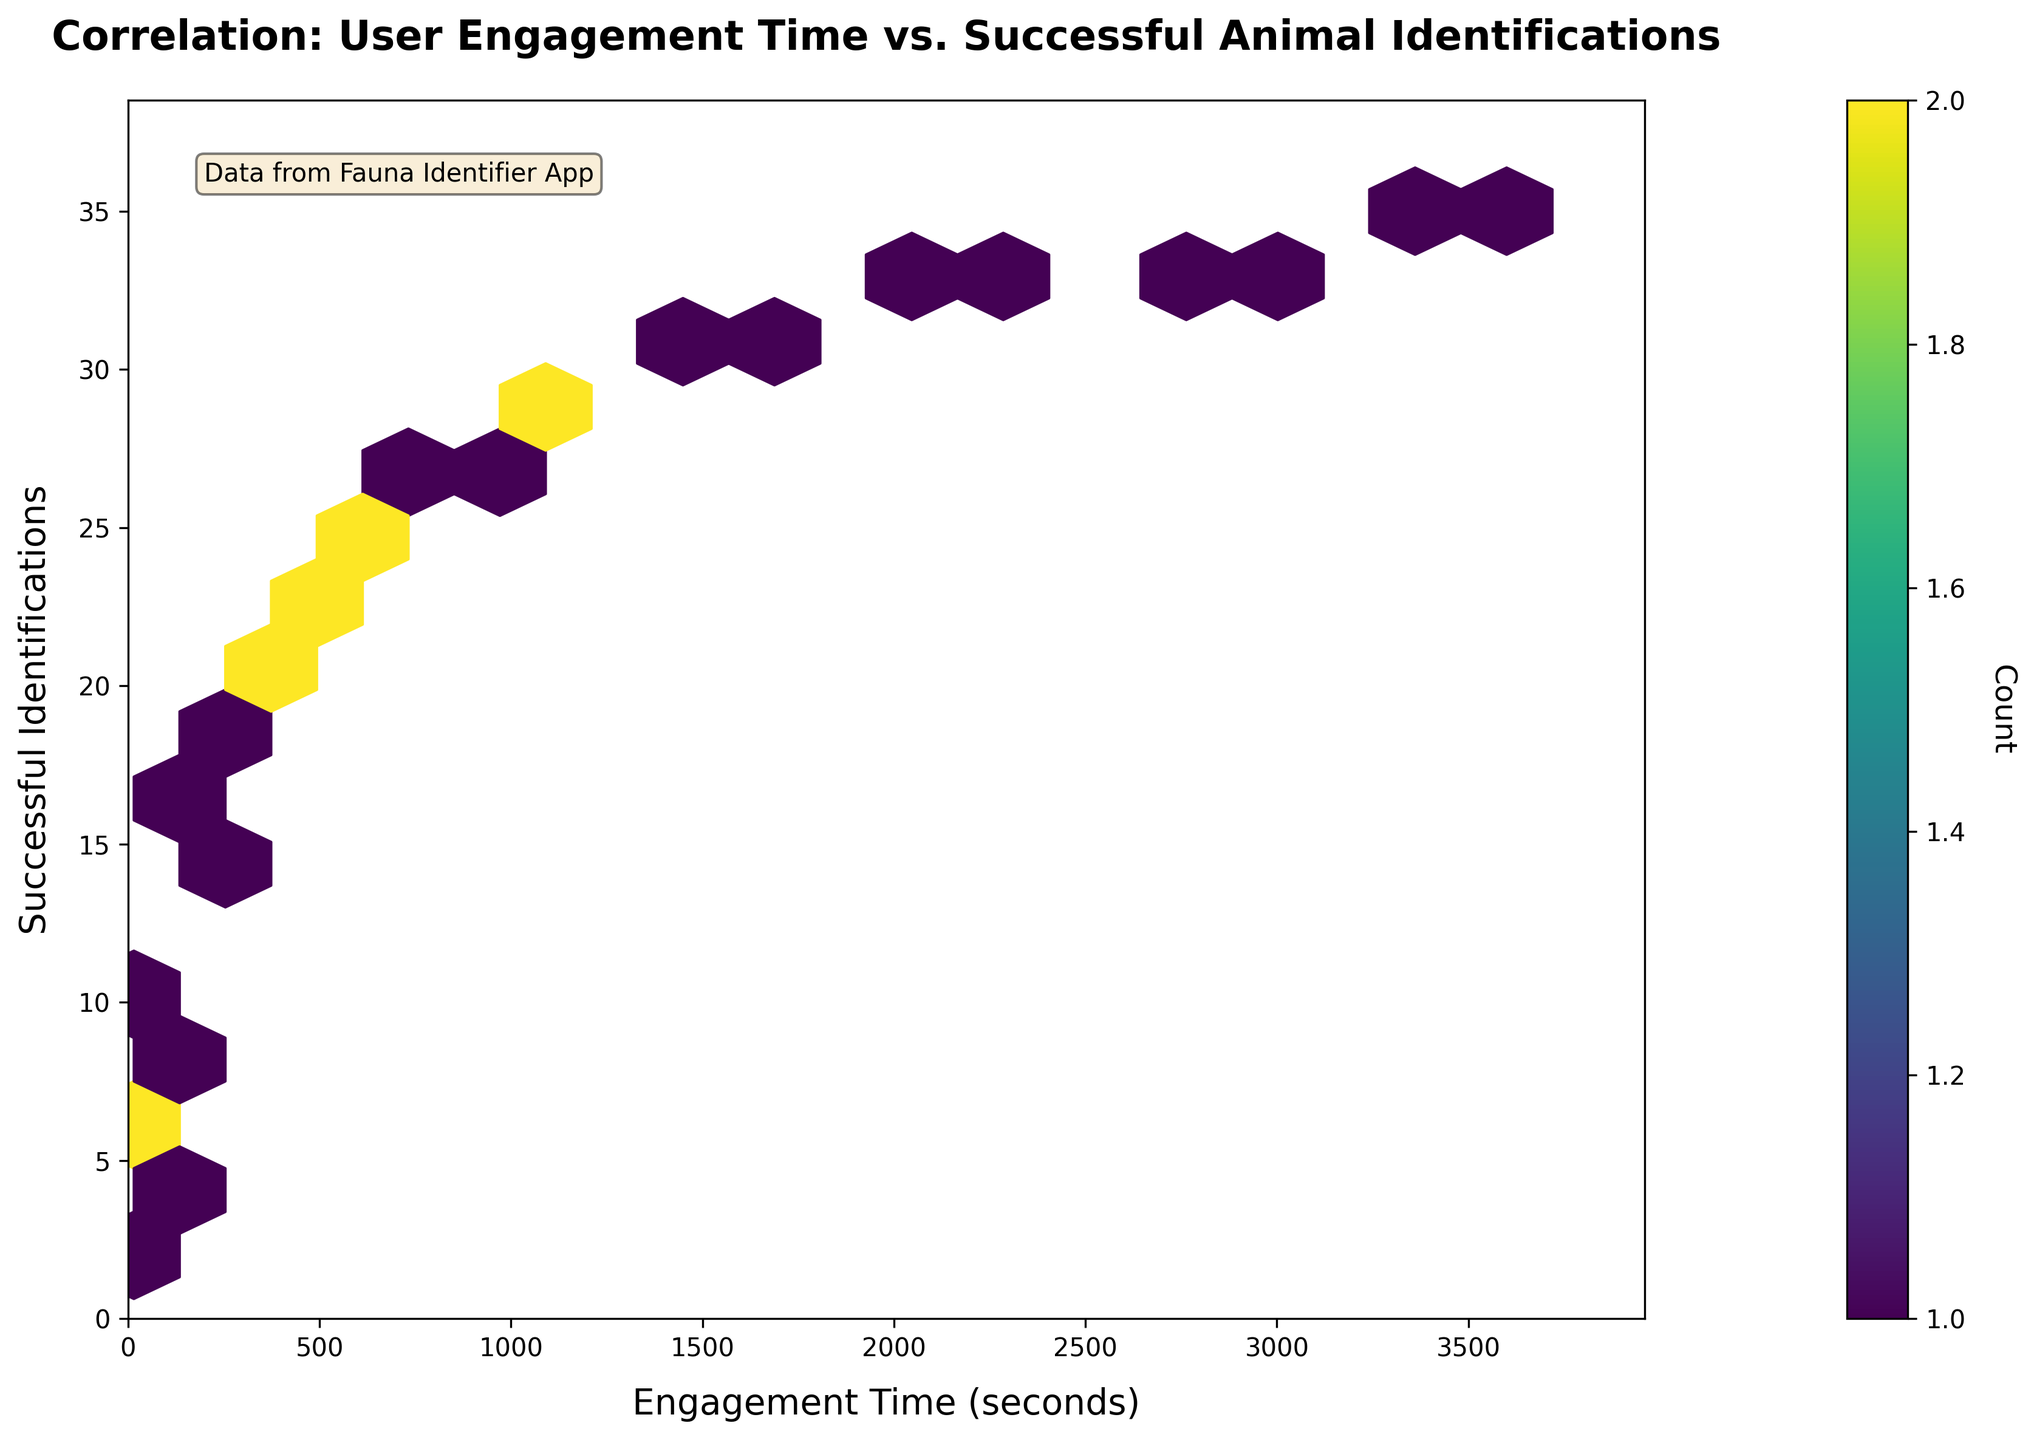What is the title of the figure? The title is displayed at the top of the figure. It reads, "Correlation: User Engagement Time vs. Successful Animal Identifications."
Answer: Correlation: User Engagement Time vs. Successful Animal Identifications What are the labels of the X and Y axes? The labels are shown along the axes. The X-axis label is "Engagement Time (seconds)," and the Y-axis label is "Successful Identifications."
Answer: Engagement Time (seconds) and Successful Identifications How does the color intensity relate to the data in the figure? The color intensity in a hexbin plot corresponds to the count of data points within each hexagonal bin. Darker hues represent higher counts.
Answer: Higher count From looking at the color bar, what does one of the darker hexagons represent? Darker hexagons signify bins with a higher density of data points. The color bar maps color intensity to the number of data points, where darker hues match higher counts.
Answer: Higher data point count Is there a cluster of data points around any specific range on the X-axis? Yes, there seems to be a higher density of data points clustering around the lower end of the X-axis, specifically between 0 and 1800 seconds of engagement time. This suggests more frequent data points within this time range.
Answer: Around 0 to 1800 seconds Do you see any outliers in the plot? Any data points or bins distant from the main cluster can be considered outliers. On this plot, there appear to be no significant outliers, as most data points follow a consistent distribution.
Answer: No significant outliers Which range on the Y-axis has the highest density of successful identifications? The highest density appears around the middle range of the Y-axis, between approximately 20 to 30 successful identifications. Darker hues in this range indicate more frequent counts.
Answer: Between 20 to 30 What does the average engagement time of users correspond to in terms of successful identifications? To determine the average, note that most bins cluster around the 1500 to 1800 seconds range, corresponding to approximately 29 to 31 successful identifications based on the darkest areas. Although this is an approximation based on visual inspection.
Answer: Approximately 1500 to 1800 seconds Is there a positive correlation between user engagement time and successful identifications? Yes, the plot shows that as engagement time increases, the number of successful identifications also tends to increase, indicating a positive correlation.
Answer: Yes What are the engagement times corresponding to the highest recorded number of successful identifications? The highest recorded number of successful identifications, according to the data, appears around 35 successful identifications. The corresponding engagement times are close to the upper limit of the dataset, around 3600 seconds.
Answer: Around 3600 seconds 